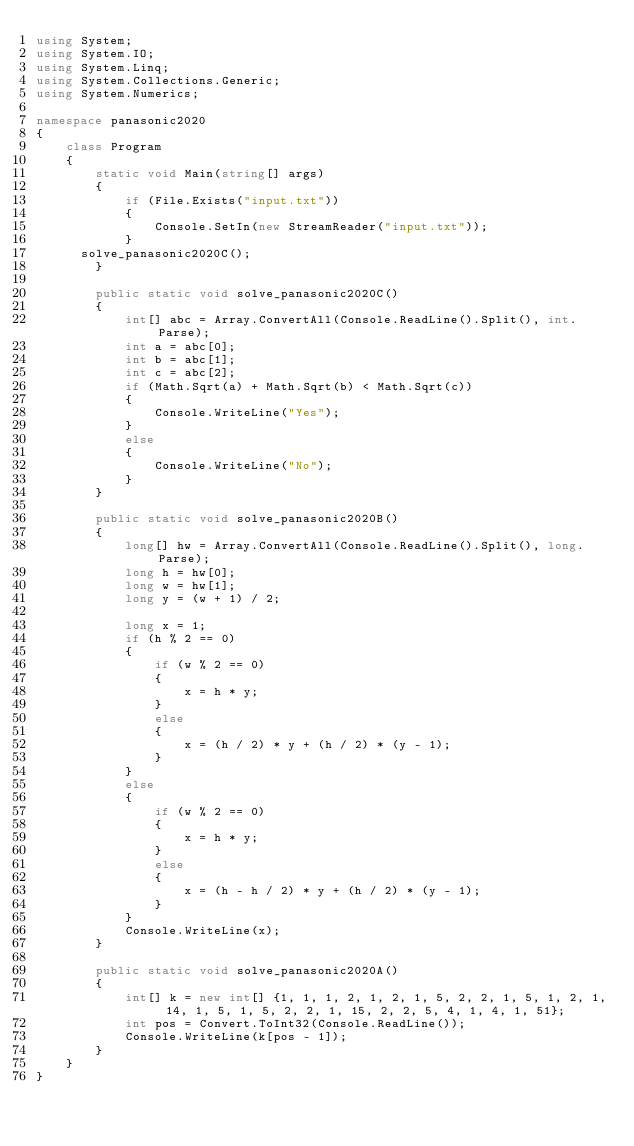<code> <loc_0><loc_0><loc_500><loc_500><_C#_>using System;
using System.IO;
using System.Linq;
using System.Collections.Generic;
using System.Numerics;

namespace panasonic2020
{
    class Program
    {
        static void Main(string[] args)
        {
            if (File.Exists("input.txt"))
            {
                Console.SetIn(new StreamReader("input.txt"));
            }
			solve_panasonic2020C();
        }

        public static void solve_panasonic2020C()
        {
            int[] abc = Array.ConvertAll(Console.ReadLine().Split(), int.Parse);
            int a = abc[0];
            int b = abc[1];
            int c = abc[2];
            if (Math.Sqrt(a) + Math.Sqrt(b) < Math.Sqrt(c))
            {
                Console.WriteLine("Yes");
            }
            else
            {
                Console.WriteLine("No");
            }
        }

        public static void solve_panasonic2020B()
        {
            long[] hw = Array.ConvertAll(Console.ReadLine().Split(), long.Parse);
            long h = hw[0];
            long w = hw[1];
            long y = (w + 1) / 2;

            long x = 1;
            if (h % 2 == 0)
            {
                if (w % 2 == 0)
                {
                    x = h * y;
                }
                else
                {
                    x = (h / 2) * y + (h / 2) * (y - 1);
                }
            }
            else
            {
                if (w % 2 == 0)
                {
                    x = h * y;
                }
                else
                {
                    x = (h - h / 2) * y + (h / 2) * (y - 1);
                }
            }
            Console.WriteLine(x);
        }

        public static void solve_panasonic2020A()
        {
            int[] k = new int[] {1, 1, 1, 2, 1, 2, 1, 5, 2, 2, 1, 5, 1, 2, 1, 14, 1, 5, 1, 5, 2, 2, 1, 15, 2, 2, 5, 4, 1, 4, 1, 51};
            int pos = Convert.ToInt32(Console.ReadLine());
            Console.WriteLine(k[pos - 1]);
        }
    }
}
</code> 